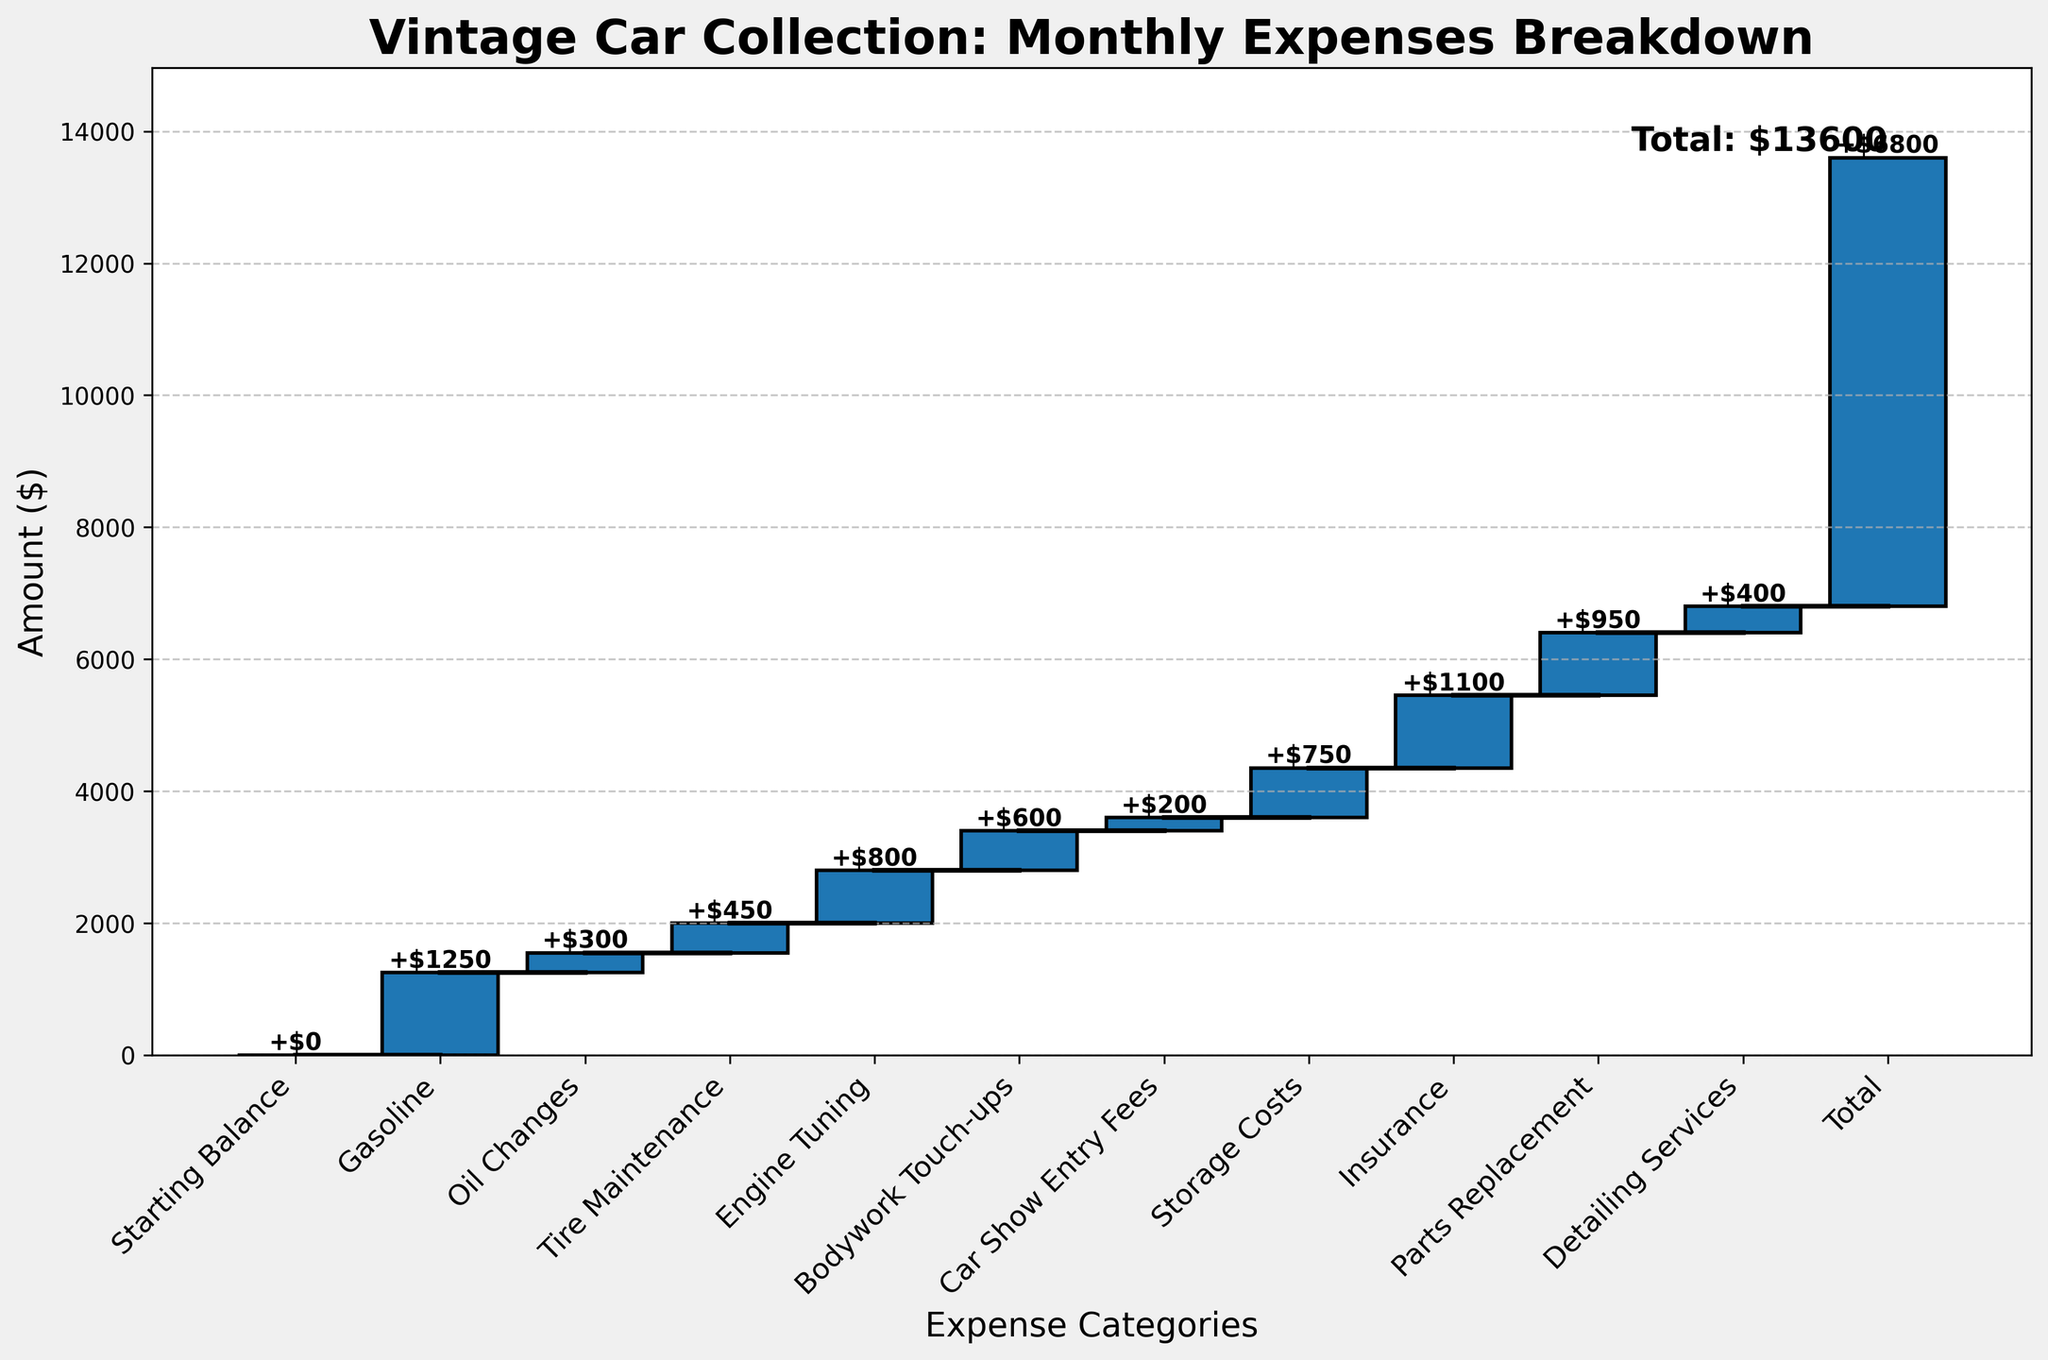What is the title of the chart? The title is placed at the top of the chart and often gives an overview of what is being displayed in the graph. In this case, it indicates that the chart is about vintage car collection expenses.
Answer: Vintage Car Collection: Monthly Expenses Breakdown What is the total monthly expense of maintaining the vintage car collection? To determine the total monthly expense, look at the category labeled 'Total' at the end. The cumulative amount next to 'Total' provides the final sum of all listed expenses.
Answer: $6800 How much is spent monthly on gasoline? The amount for each category is displayed in the bar corresponding to that category. Locate the bar labeled 'Gasoline' to find the amount.
Answer: $1250 Which expense category has the highest cost? By comparing the values of each bar, the category with the tallest bar represents the highest cost.
Answer: Insurance What is the cumulative expense after Tire Maintenance? To find this, look for the cumulative expense at the top of the 'Tire Maintenance' bar, which is the cumulative sum of the expenses up to and including Tire Maintenance.
Answer: $2000 How does the cost of Engine Tuning compare to the cost of Bodywork Touch-ups? Identify the amounts for both 'Engine Tuning' and 'Bodywork Touch-ups' and compare them. Engine Tuning costs $800 and Bodywork Touch-ups costs $600, so Engine Tuning is more expensive.
Answer: $800 is greater than $600 What is the combined cost of Oil Changes and Parts Replacement? Add the costs of 'Oil Changes' and 'Parts Replacement' together. Oil Changes cost $300, and Parts Replacement costs $950.
Answer: $1250 What is the expense category right before Insurance? The categories are listed in order on the x-axis. The category just before 'Insurance' would be the one immediately to its left.
Answer: Storage Costs How much less is spent on Car Show Entry Fees compared to Insurance? Subtract the cost of 'Car Show Entry Fees' from 'Insurance'. Car Show Entry Fees are $200, and Insurance is $1100, so the difference is $1100 - $200.
Answer: $900 What percentage of the total expenses is spent on Storage Costs? To find this, divide the amount spent on Storage Costs by the total expense and then multiply by 100 to get the percentage. Storage Costs are $750, and the total expense is $6800. So, (750/6800) * 100.
Answer: 11.03% 